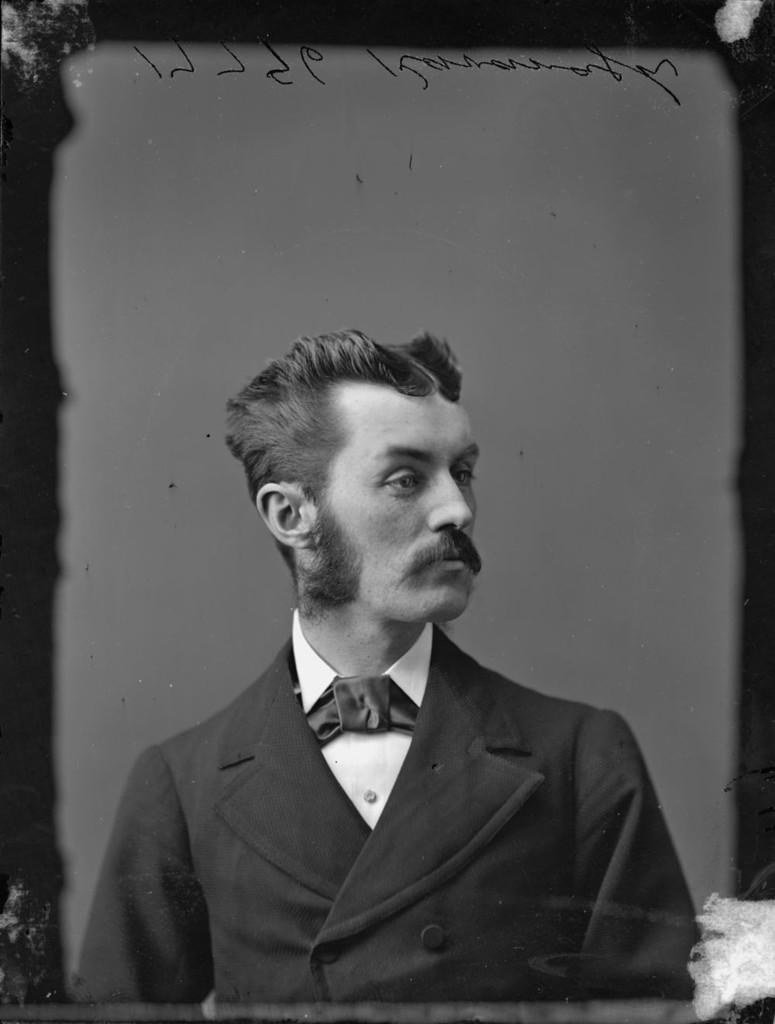Who or what is present in the image? There is a person in the image. What can be seen at the top of the image? There is some text at the top of the image. What type of locket is hanging from the wire in the image? There is no locket or wire present in the image. How many cubs can be seen playing with the person in the image? There are no cubs present in the image. 